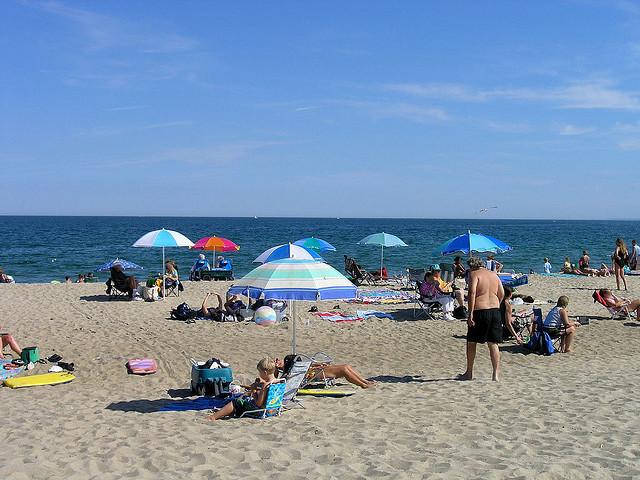Why are some people laying on the sand?
Be succinct. Sunbathing. How many umbrellas are rainbow?
Write a very short answer. 0. What color is the ocean?
Answer briefly. Blue. How many umbrellas are there?
Be succinct. 7. 